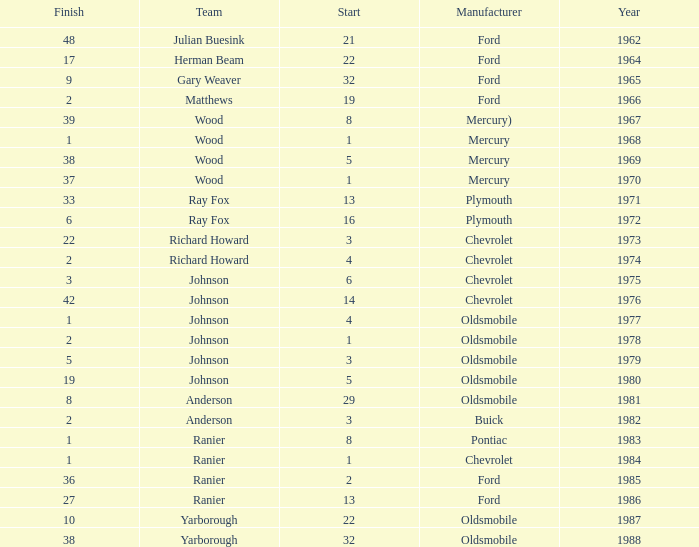Who was the maufacturer of the vehicle during the race where Cale Yarborough started at 19 and finished earlier than 42? Ford. 